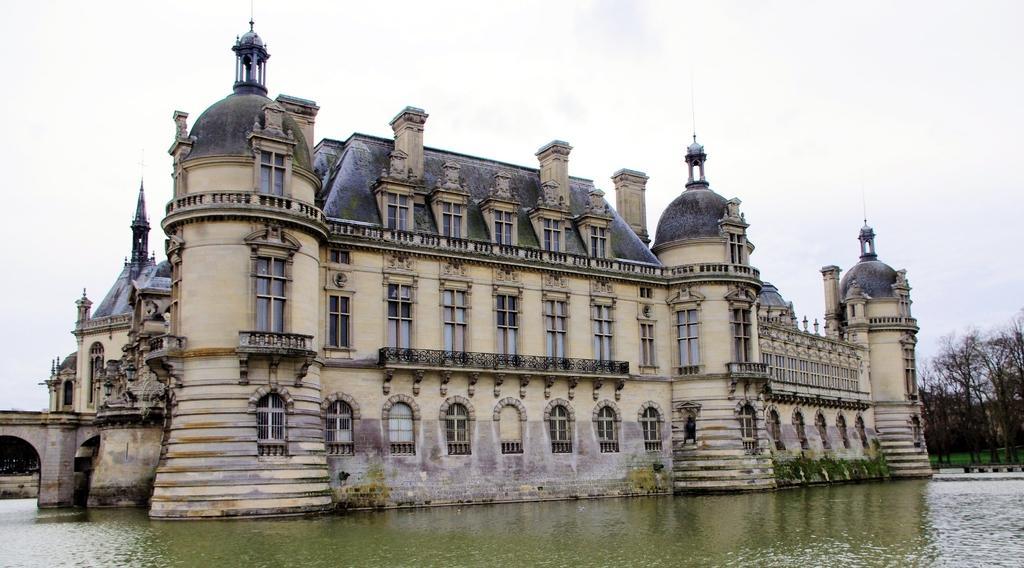In one or two sentences, can you explain what this image depicts? In this image in the center there is a palace, and on the left side there is a bridge. At the bottom there is a river and on the right side there is grass and trees, at the top there is sky. 